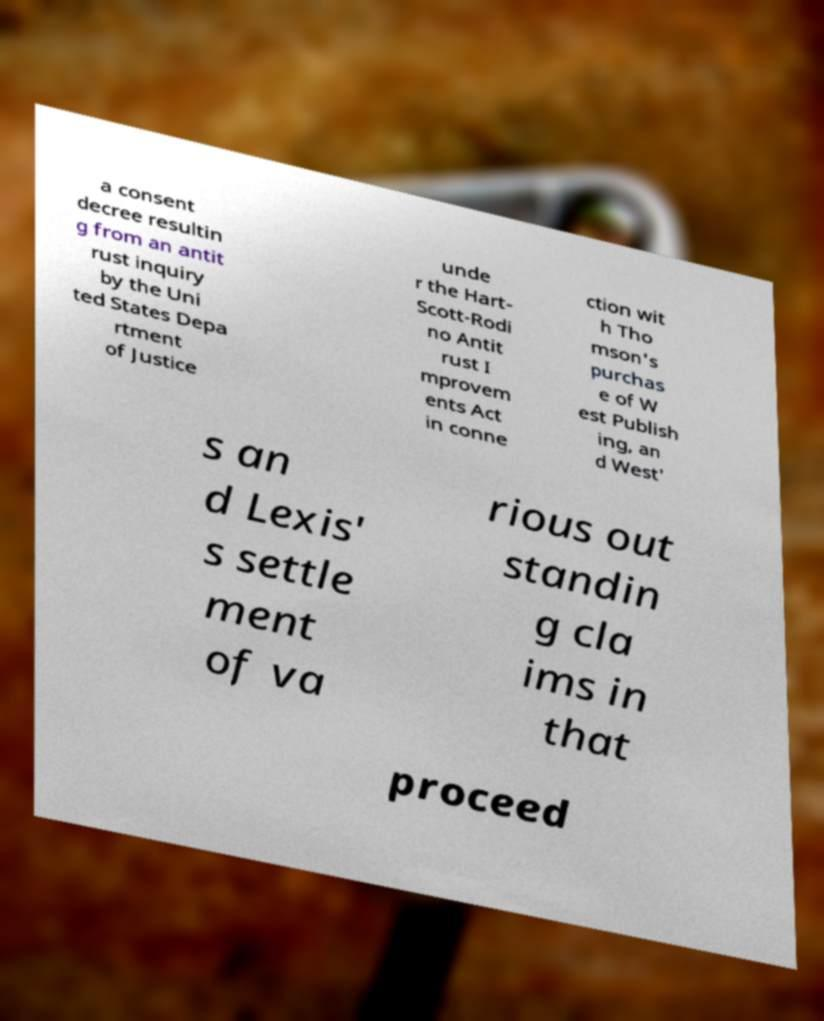Can you read and provide the text displayed in the image?This photo seems to have some interesting text. Can you extract and type it out for me? a consent decree resultin g from an antit rust inquiry by the Uni ted States Depa rtment of Justice unde r the Hart- Scott-Rodi no Antit rust I mprovem ents Act in conne ction wit h Tho mson's purchas e of W est Publish ing, an d West' s an d Lexis' s settle ment of va rious out standin g cla ims in that proceed 